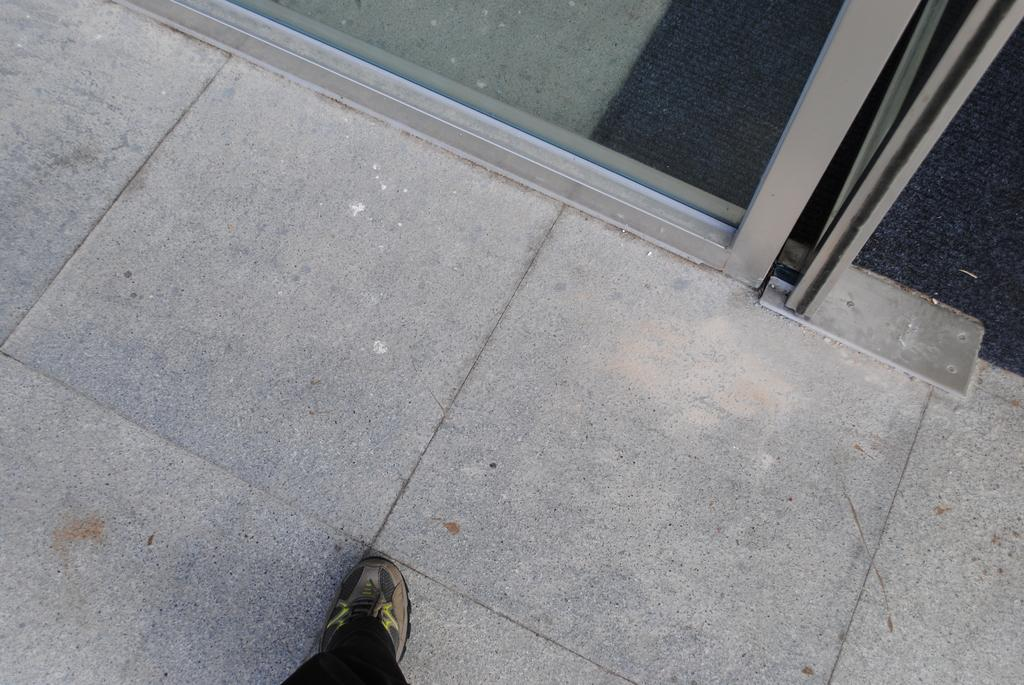What type of surface is visible in the image? There is a floor in the image. What material is present in the image that is transparent? There is glass in the image. What type of covering is on the floor in the image? There is a carpet in the image. What type of footwear can be seen in the image? There is a shoe in the image. What word is written on the shoe in the image? There is no word written on the shoe in the image. What type of pet can be seen in the image? There is no pet present in the image. 